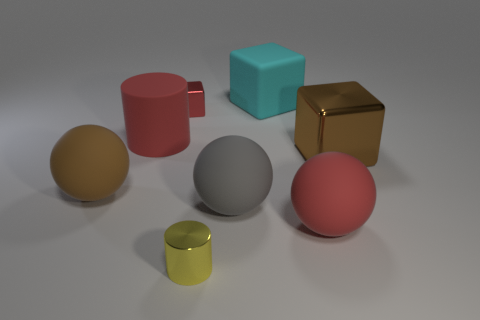Add 2 brown cylinders. How many objects exist? 10 Subtract all red spheres. How many spheres are left? 2 Subtract 1 cubes. How many cubes are left? 2 Add 8 brown rubber things. How many brown rubber things are left? 9 Add 3 brown balls. How many brown balls exist? 4 Subtract all red blocks. How many blocks are left? 2 Subtract 1 cyan blocks. How many objects are left? 7 Subtract all cubes. How many objects are left? 5 Subtract all green spheres. Subtract all yellow blocks. How many spheres are left? 3 Subtract all yellow cubes. How many red cylinders are left? 1 